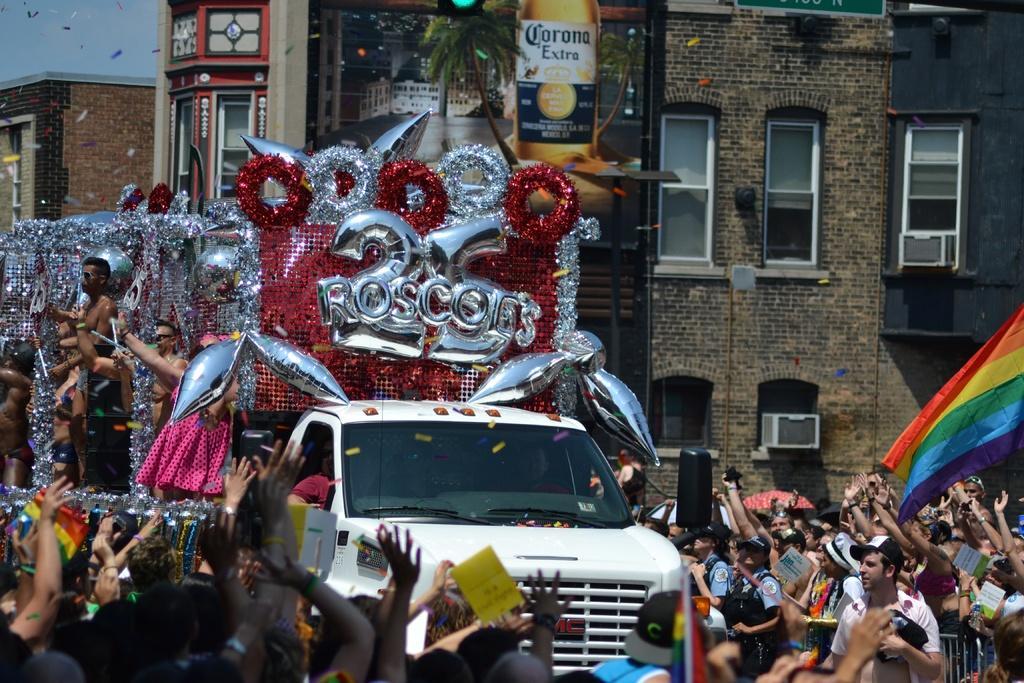Describe this image in one or two sentences. In the center of the image we can see a vehicle decorated and there are people in the vehicle. At the bottom there is crowd. On the right there is a flag. In the background there are buildings, trees and sky. 